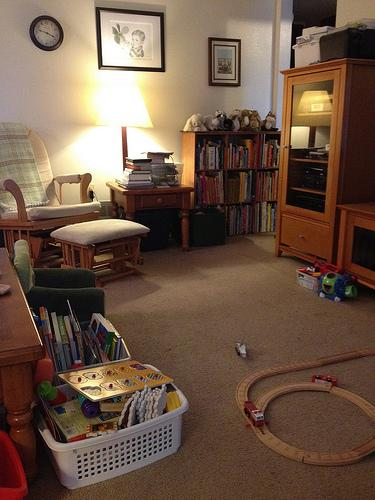What type of furniture is present in the image for displaying books? A small wooden bookcase and a shelf full of books are present for displaying books. Describe the position and characteristics of the clock in the image. The clock is positioned on the wall near the top left corner, with a white face and a black frame. Identify an object in the image that has a train and specify its color. There are brown train tracks with a train in the image. Mention an item in the image that is used for storage and its contents. There is a white plastic basket filled with toys for storage. What is the color of the carpet in the room? The carpet in the room is brown. Name an object in the image that is suitable for children to sit on. A small green kids chair is suitable for children to sit on. What type of artwork is present on the white wall? There is framed art on the white wall. Identify the primary feature of the room depicted in the image. The primary feature of the room is the family room full of books and toys. Is the floor covered with a dark grey carpet that looks brand new? The floor is covered with brown berber carpet, not dark grey, and it looks like it has been used, not brand new. Is the puzzle with green knobs lying on the floor next to the toy car? The puzzle in the image has red knobs, not green. The puzzle is also not lying on the floor next to the toy car, but on top of a basket. Look for a large bookcase in the center of the picture that's nearly empty. The bookcase in the image is a small wooden bookcase and it is full of books, not nearly empty. Identify the small red and yellow kids' chair placed near the books. The kids' chair in the image is not red and yellow; it is green. It is also not placed near books, but near toys. Find the big clock hanging above the lamp in the living room. The clock in the image is not hanging above the lamp; it is located on the wall to the left of the lamp. Can you find a half-open brown drawer on the end table with a book on top of it? The drawer in the image is not half-open. There is no book on top of the brown drawer on the end table either. Can you spot the blue laundry basket overflowing with toys on the right side of the image? There is no blue laundry basket in the image. The actual laundry basket is white and full of kids' stuff. Locate the giant plush teddy bear in the middle of the room, resting on a white sofa. There is no giant plush teddy bear or white sofa in the image. The stuffed animals are sitting on a shelf instead. In the photo, can you see a tall, modern floor lamp standing next to the small chair? The lamp in the image is not a tall, modern floor lamp. It is a regular-sized lamp with a reflection in the glass. Is there a purple toy car lying upside down somewhere in the picture? There is no purple toy car in the image. The actual toy car is red and on its side, not upside down. 